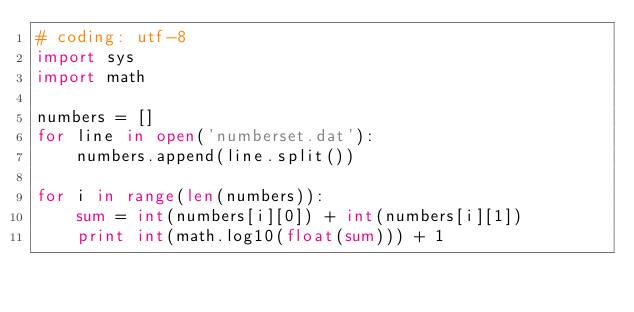Convert code to text. <code><loc_0><loc_0><loc_500><loc_500><_Python_># coding: utf-8
import sys
import math

numbers = []
for line in open('numberset.dat'):
    numbers.append(line.split())

for i in range(len(numbers)):
    sum = int(numbers[i][0]) + int(numbers[i][1])
    print int(math.log10(float(sum))) + 1</code> 